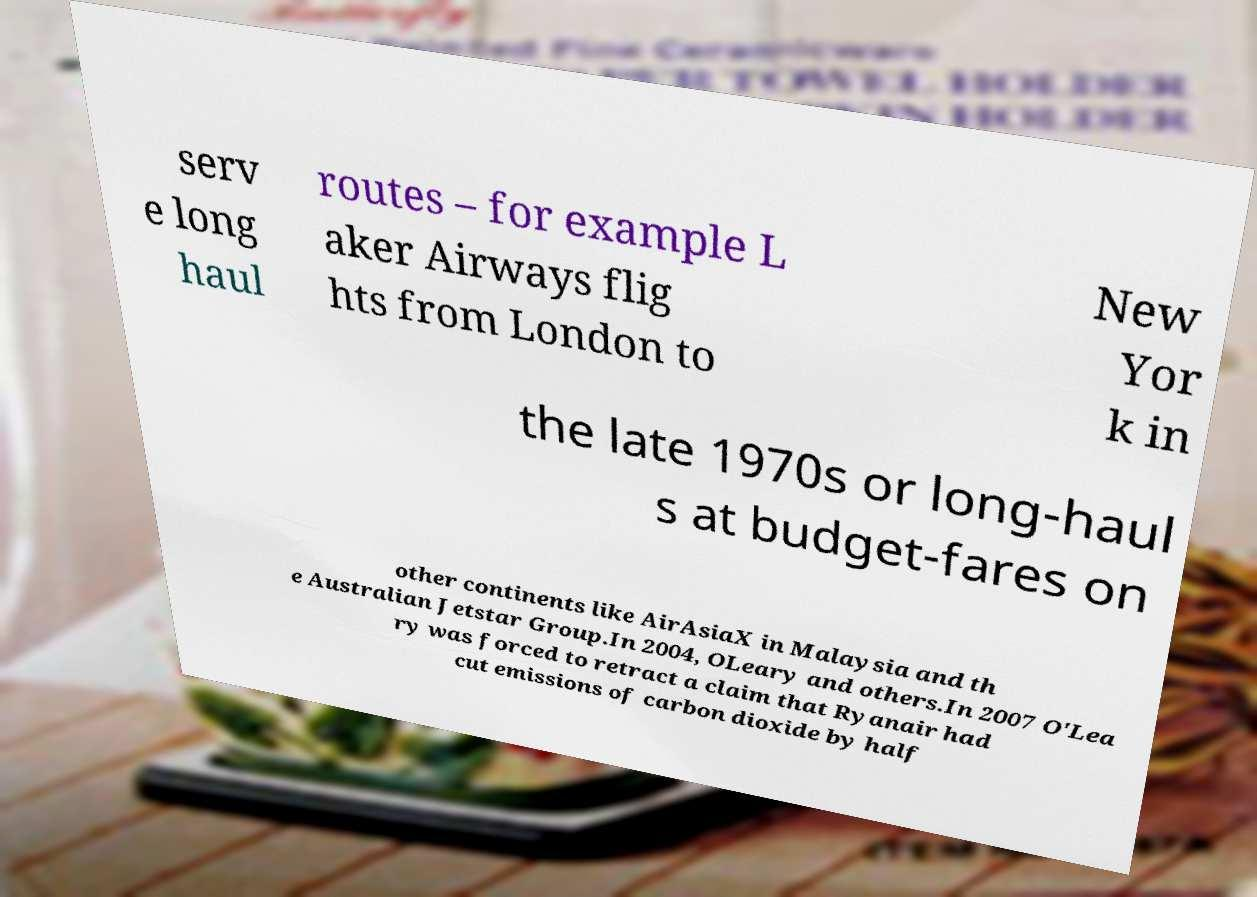Can you accurately transcribe the text from the provided image for me? serv e long haul routes – for example L aker Airways flig hts from London to New Yor k in the late 1970s or long-haul s at budget-fares on other continents like AirAsiaX in Malaysia and th e Australian Jetstar Group.In 2004, OLeary and others.In 2007 O'Lea ry was forced to retract a claim that Ryanair had cut emissions of carbon dioxide by half 